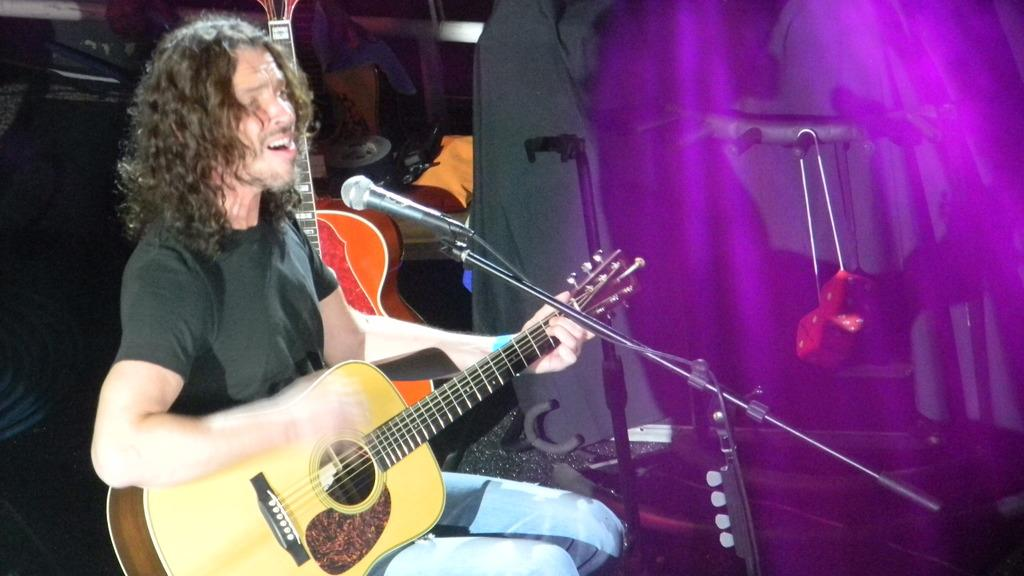What is the man in the image doing? The man is singing on a mic and playing a guitar. Are there any other people in the image? Yes, there are people behind the man. What else can be seen in the image besides the people? There are musical instruments present. What type of flag is being waved by the brass band in the cemetery? There is no flag, brass band, or cemetery present in the image. 